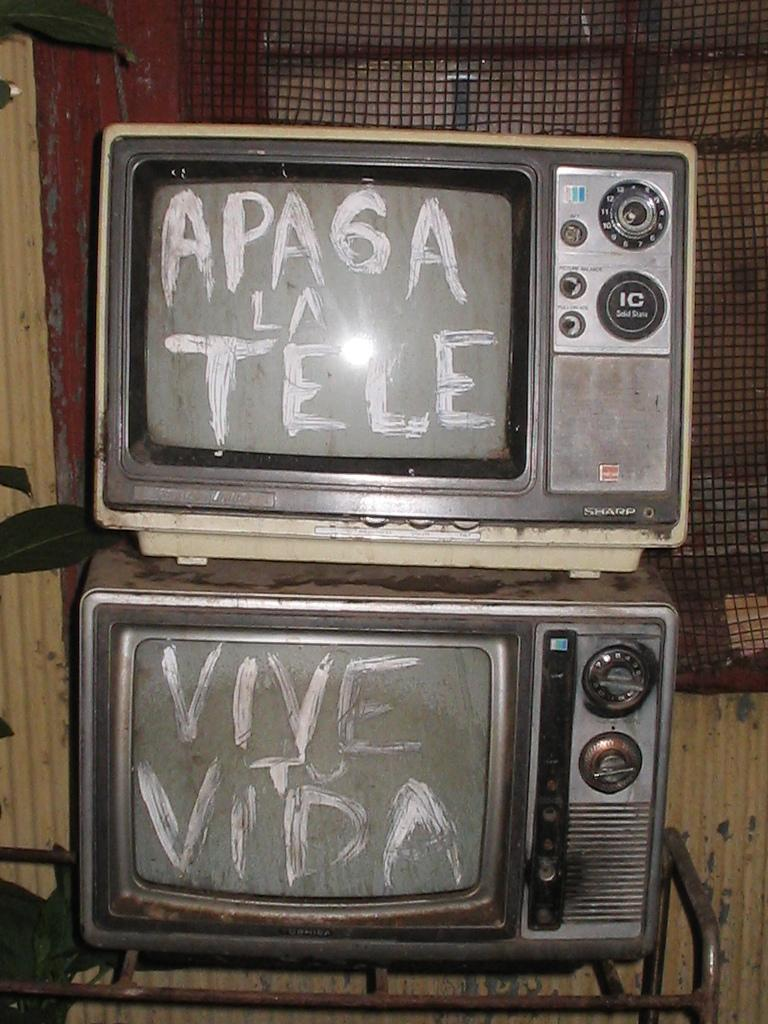Provide a one-sentence caption for the provided image. Two old fashioned TVs have white paint that says Vive To Vida and Apa6a La Tele. 